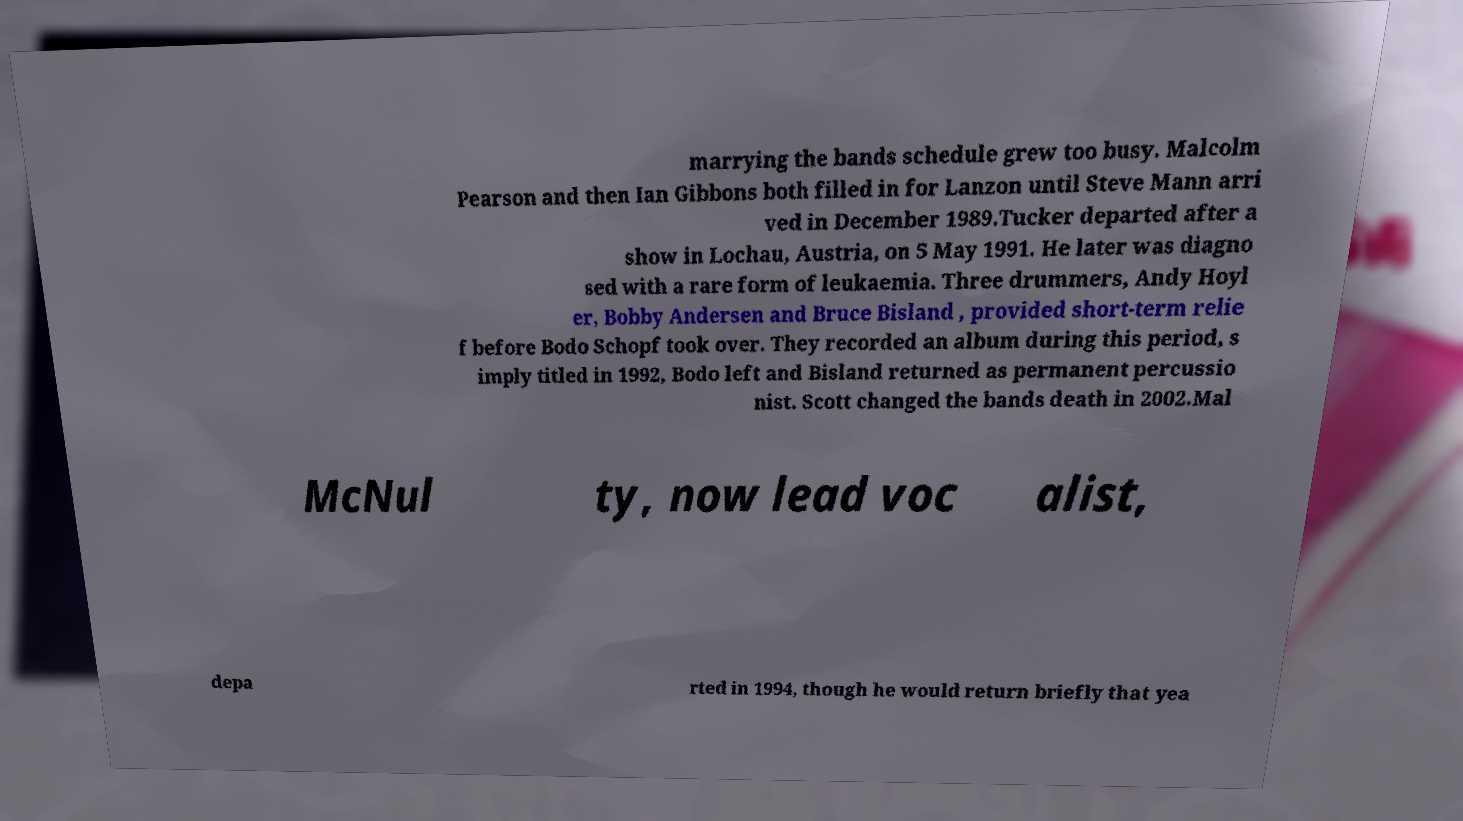Please identify and transcribe the text found in this image. marrying the bands schedule grew too busy. Malcolm Pearson and then Ian Gibbons both filled in for Lanzon until Steve Mann arri ved in December 1989.Tucker departed after a show in Lochau, Austria, on 5 May 1991. He later was diagno sed with a rare form of leukaemia. Three drummers, Andy Hoyl er, Bobby Andersen and Bruce Bisland , provided short-term relie f before Bodo Schopf took over. They recorded an album during this period, s imply titled in 1992, Bodo left and Bisland returned as permanent percussio nist. Scott changed the bands death in 2002.Mal McNul ty, now lead voc alist, depa rted in 1994, though he would return briefly that yea 